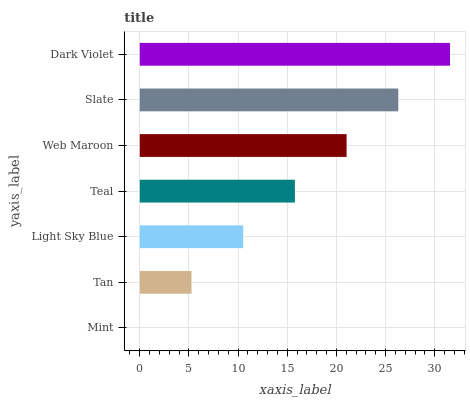Is Mint the minimum?
Answer yes or no. Yes. Is Dark Violet the maximum?
Answer yes or no. Yes. Is Tan the minimum?
Answer yes or no. No. Is Tan the maximum?
Answer yes or no. No. Is Tan greater than Mint?
Answer yes or no. Yes. Is Mint less than Tan?
Answer yes or no. Yes. Is Mint greater than Tan?
Answer yes or no. No. Is Tan less than Mint?
Answer yes or no. No. Is Teal the high median?
Answer yes or no. Yes. Is Teal the low median?
Answer yes or no. Yes. Is Light Sky Blue the high median?
Answer yes or no. No. Is Web Maroon the low median?
Answer yes or no. No. 